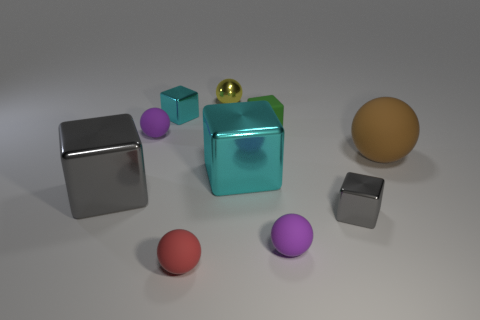What is the size of the gray object that is to the left of the gray metal block that is to the right of the purple matte sphere that is to the left of the tiny yellow sphere?
Provide a short and direct response. Large. What number of blue things are blocks or big balls?
Offer a very short reply. 0. Is the shape of the gray thing that is left of the tiny red ball the same as  the brown rubber object?
Offer a very short reply. No. Is the number of large brown rubber objects behind the green thing greater than the number of large cyan cubes?
Ensure brevity in your answer.  No. What number of purple spheres have the same size as the green matte object?
Provide a succinct answer. 2. What number of things are either cyan metallic objects or small purple spheres on the left side of the tiny gray object?
Make the answer very short. 4. The shiny object that is both in front of the tiny yellow sphere and behind the small green rubber block is what color?
Keep it short and to the point. Cyan. Is the green matte cube the same size as the shiny sphere?
Your answer should be very brief. Yes. What color is the big metallic cube that is right of the shiny sphere?
Keep it short and to the point. Cyan. Is there a small metallic object that has the same color as the tiny rubber cube?
Make the answer very short. No. 